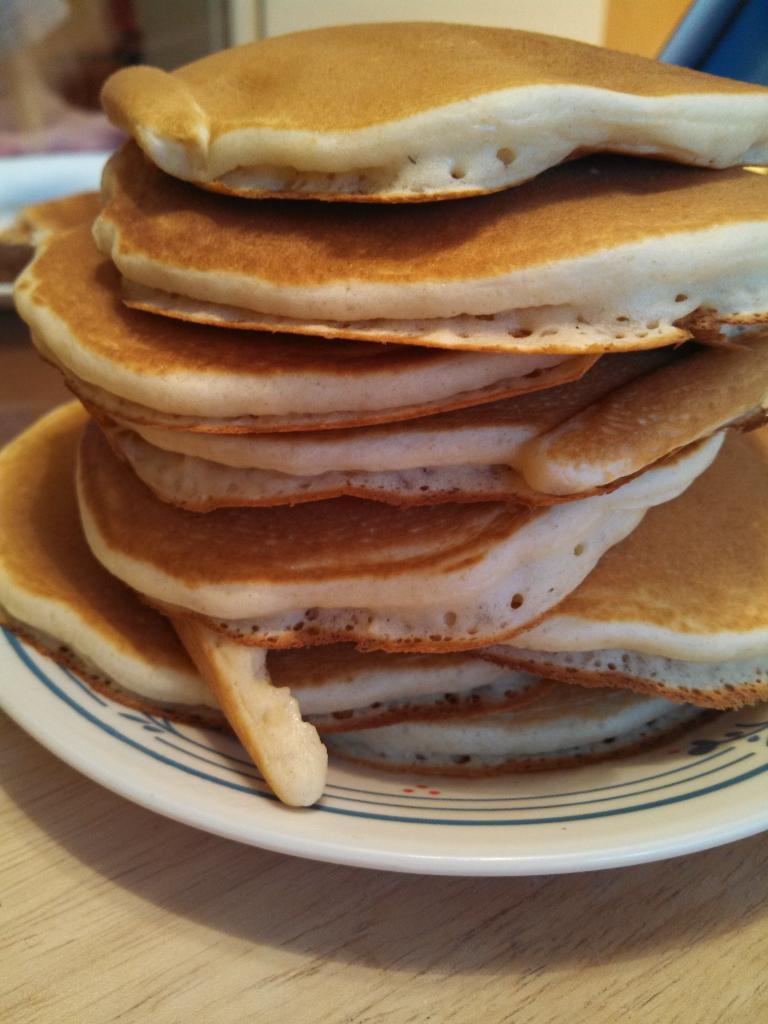How would you summarize this image in a sentence or two? In this image I can see a cream colored surface and on it I can see a plate which is white in color. On the plate I can see few pancakes which are brown and white in color. In the background I can see the cream colored wall and few other objects. 